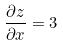Convert formula to latex. <formula><loc_0><loc_0><loc_500><loc_500>\frac { \partial z } { \partial x } = 3</formula> 